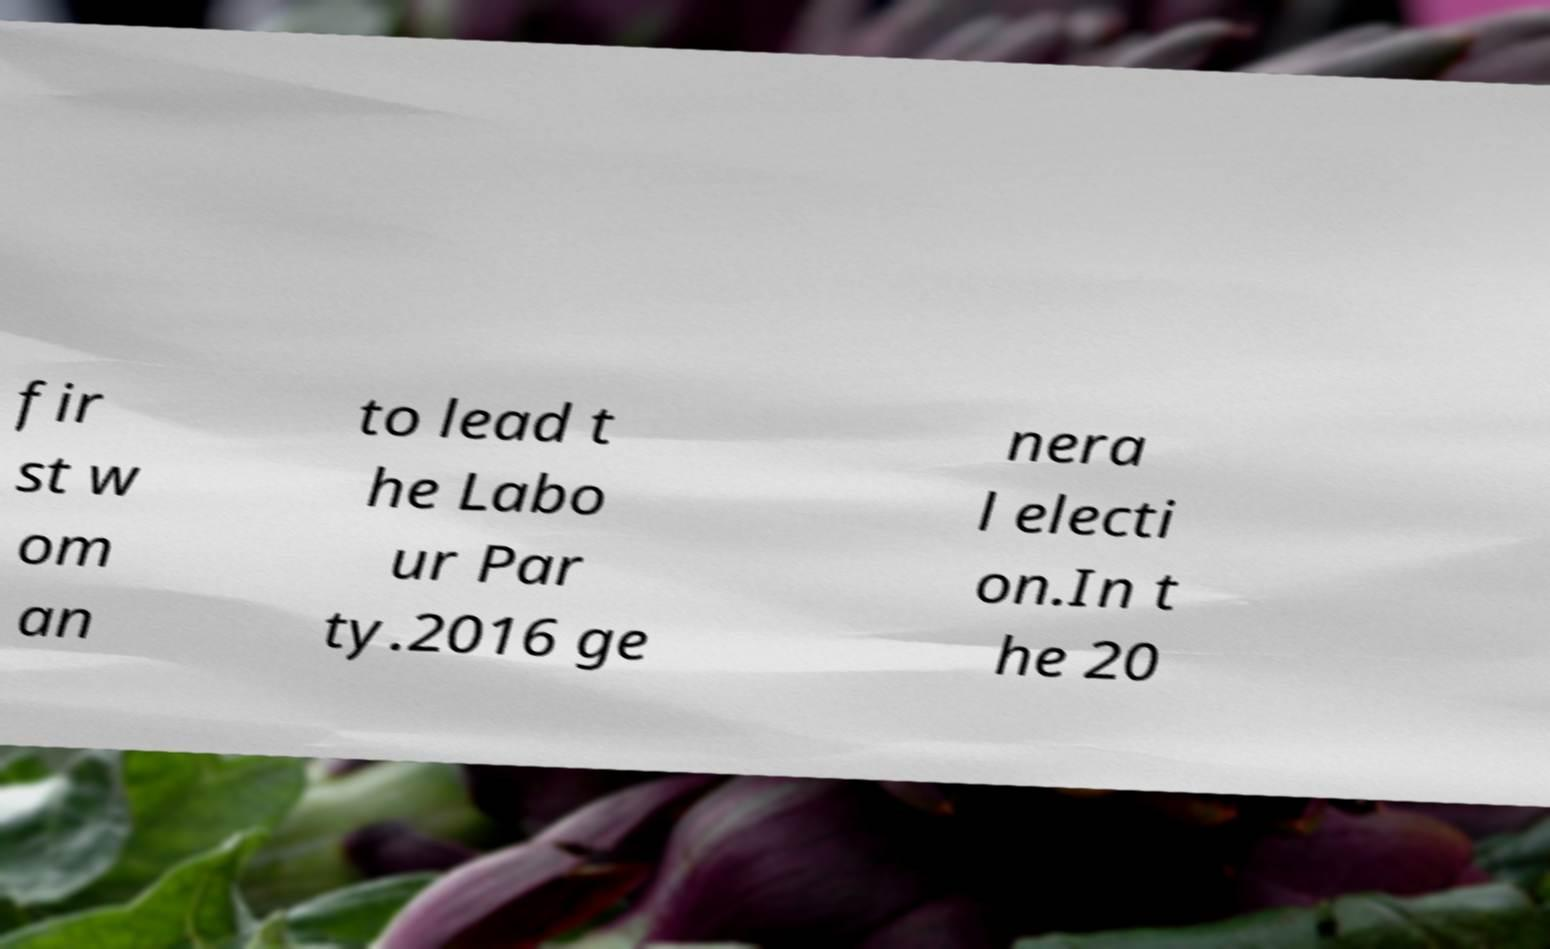Please read and relay the text visible in this image. What does it say? fir st w om an to lead t he Labo ur Par ty.2016 ge nera l electi on.In t he 20 